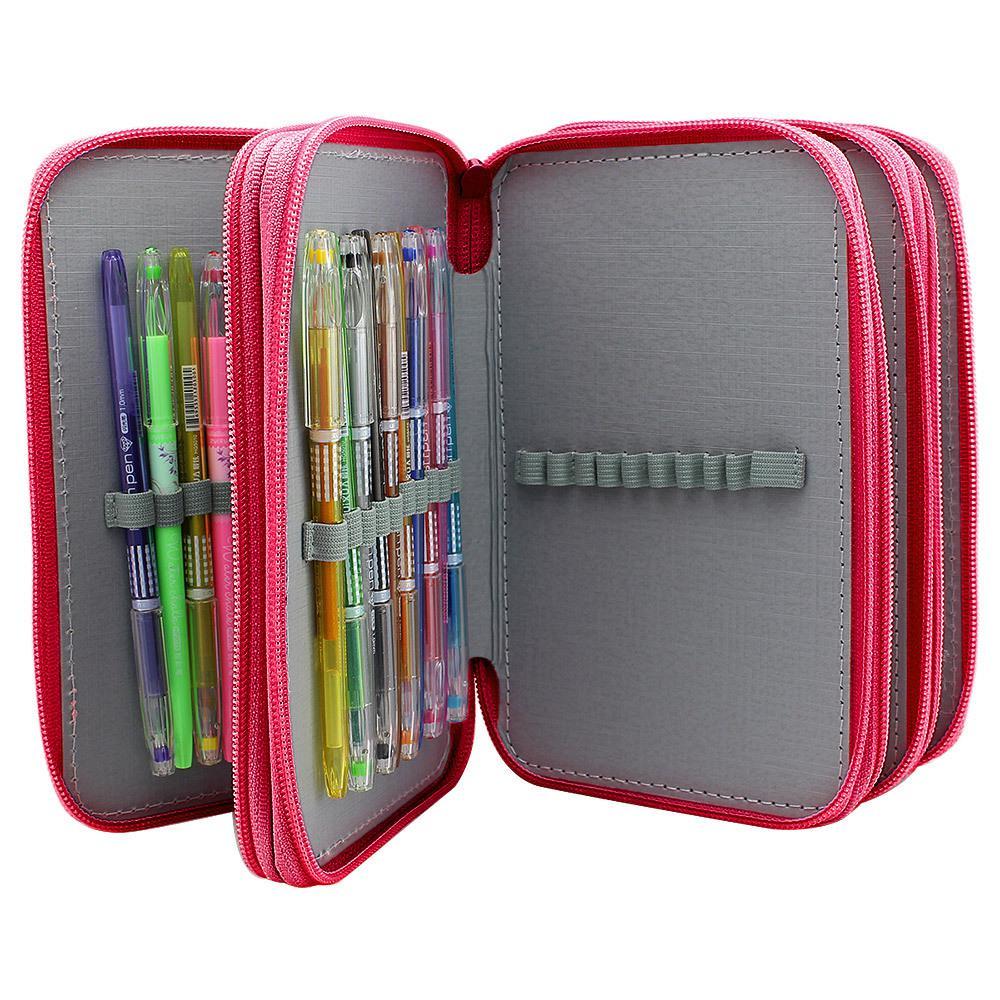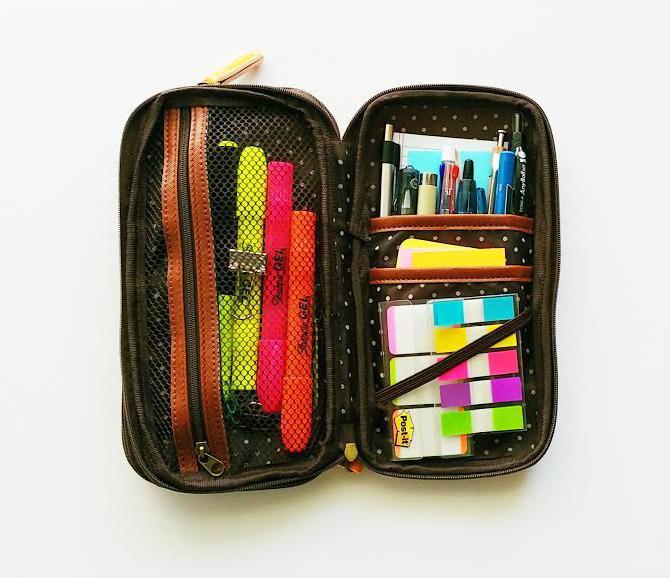The first image is the image on the left, the second image is the image on the right. Given the left and right images, does the statement "Each image includes a closed zipper case to the right of an open, filled pencil case." hold true? Answer yes or no. No. 